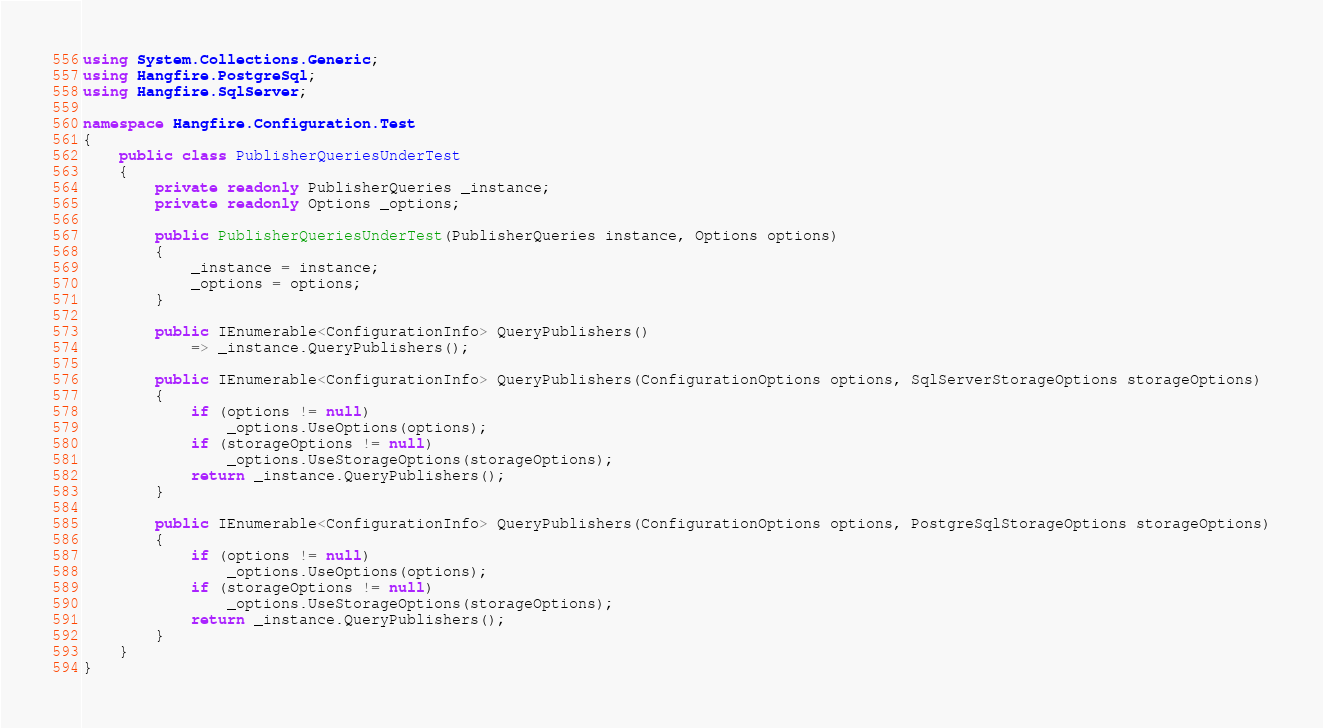<code> <loc_0><loc_0><loc_500><loc_500><_C#_>using System.Collections.Generic;
using Hangfire.PostgreSql;
using Hangfire.SqlServer;

namespace Hangfire.Configuration.Test
{
    public class PublisherQueriesUnderTest
    {
        private readonly PublisherQueries _instance;
        private readonly Options _options;

        public PublisherQueriesUnderTest(PublisherQueries instance, Options options)
        {
            _instance = instance;
            _options = options;
        }

        public IEnumerable<ConfigurationInfo> QueryPublishers()
            => _instance.QueryPublishers();
        
        public IEnumerable<ConfigurationInfo> QueryPublishers(ConfigurationOptions options, SqlServerStorageOptions storageOptions)
        {
            if (options != null)
                _options.UseOptions(options);
            if (storageOptions != null)
                _options.UseStorageOptions(storageOptions);
            return _instance.QueryPublishers();
        }

        public IEnumerable<ConfigurationInfo> QueryPublishers(ConfigurationOptions options, PostgreSqlStorageOptions storageOptions)
        {
	        if (options != null)
		        _options.UseOptions(options);
	        if (storageOptions != null)
		        _options.UseStorageOptions(storageOptions);
	        return _instance.QueryPublishers();
        }
	}
}</code> 